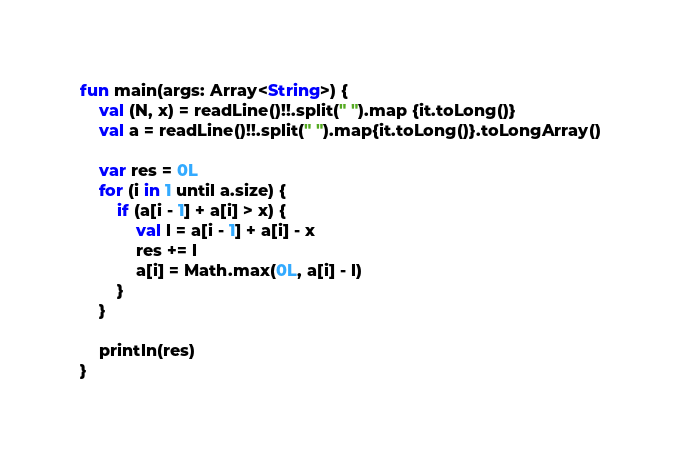<code> <loc_0><loc_0><loc_500><loc_500><_Kotlin_>fun main(args: Array<String>) {
    val (N, x) = readLine()!!.split(" ").map {it.toLong()}
    val a = readLine()!!.split(" ").map{it.toLong()}.toLongArray()

    var res = 0L
    for (i in 1 until a.size) {
        if (a[i - 1] + a[i] > x) {
            val l = a[i - 1] + a[i] - x
            res += l
            a[i] = Math.max(0L, a[i] - l)
        }
    }

    println(res)
}</code> 